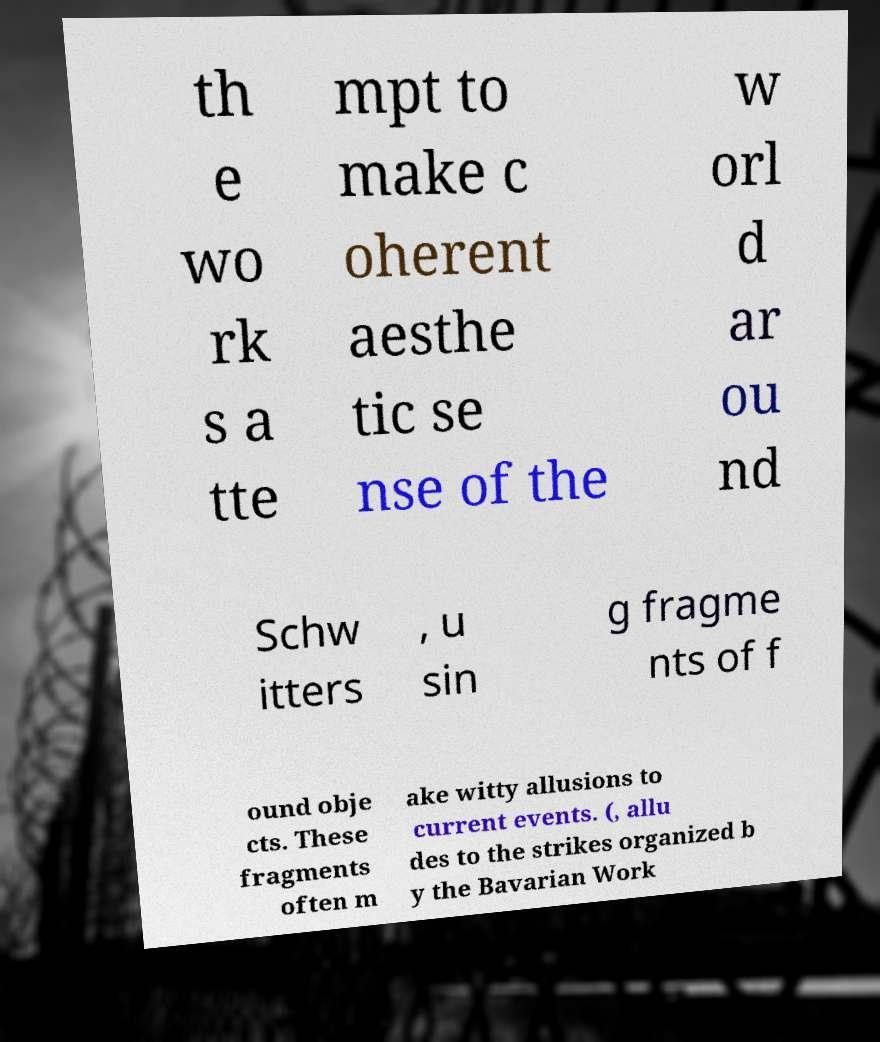What messages or text are displayed in this image? I need them in a readable, typed format. th e wo rk s a tte mpt to make c oherent aesthe tic se nse of the w orl d ar ou nd Schw itters , u sin g fragme nts of f ound obje cts. These fragments often m ake witty allusions to current events. (, allu des to the strikes organized b y the Bavarian Work 